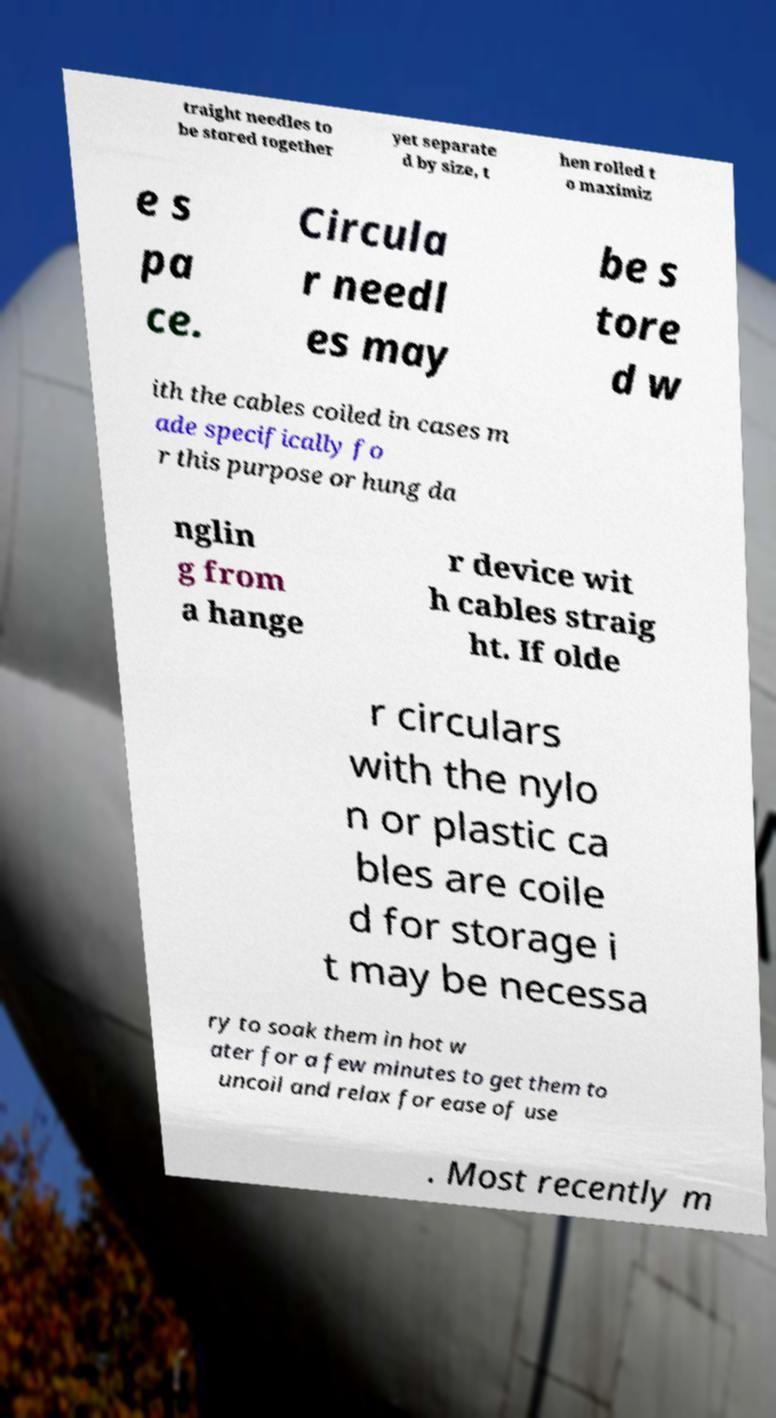Could you extract and type out the text from this image? traight needles to be stored together yet separate d by size, t hen rolled t o maximiz e s pa ce. Circula r needl es may be s tore d w ith the cables coiled in cases m ade specifically fo r this purpose or hung da nglin g from a hange r device wit h cables straig ht. If olde r circulars with the nylo n or plastic ca bles are coile d for storage i t may be necessa ry to soak them in hot w ater for a few minutes to get them to uncoil and relax for ease of use . Most recently m 